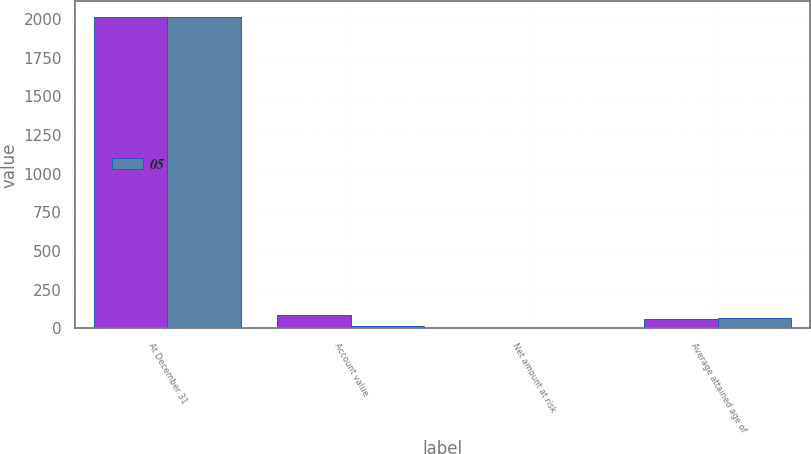Convert chart to OTSL. <chart><loc_0><loc_0><loc_500><loc_500><stacked_bar_chart><ecel><fcel>At December 31<fcel>Account value<fcel>Net amount at risk<fcel>Average attained age of<nl><fcel>nan<fcel>2014<fcel>85<fcel>1<fcel>62<nl><fcel>5<fcel>2014<fcel>17<fcel>1<fcel>68<nl></chart> 